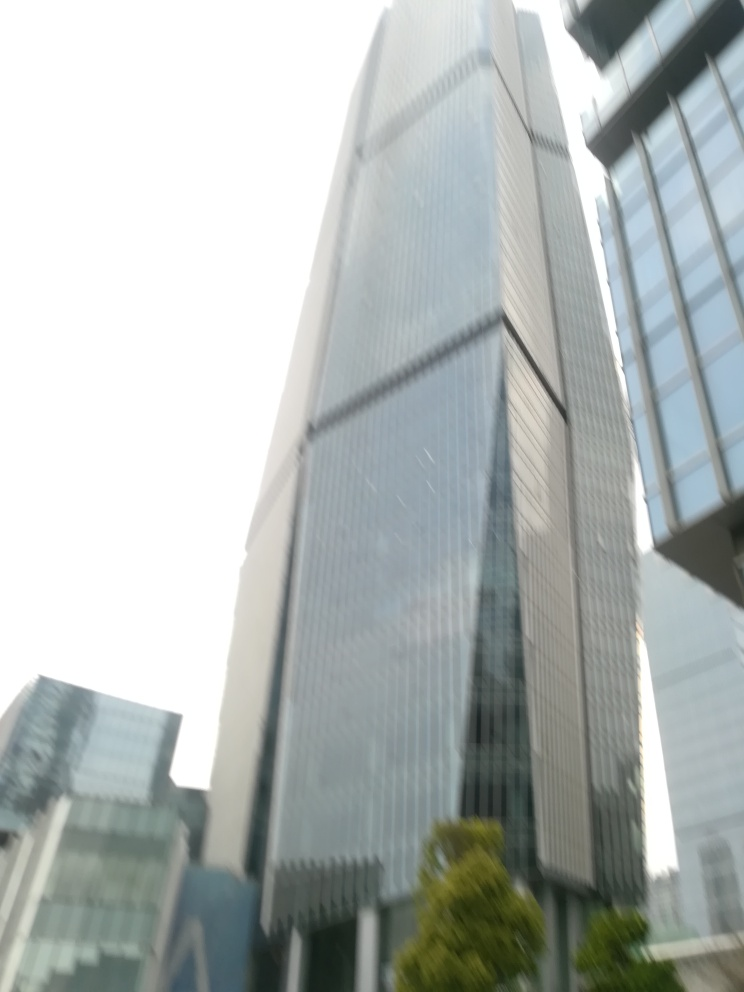What is the architectural style of the building in the image? The building exhibits characteristics of contemporary architecture, with a sleek, modern facade and the use of glass as a primary material for external walls, which allows for natural light and reflects the building's surroundings. 